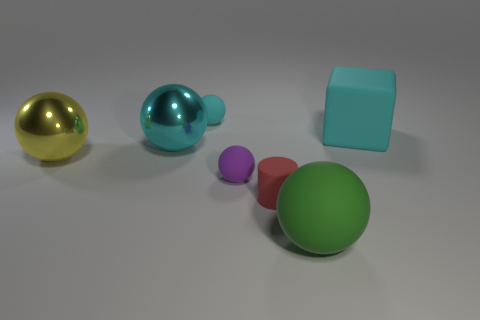Add 1 big yellow matte spheres. How many objects exist? 8 Subtract all small cyan balls. How many balls are left? 4 Subtract all blocks. How many objects are left? 6 Subtract all yellow spheres. How many spheres are left? 4 Subtract all cyan blocks. How many green balls are left? 1 Subtract all matte spheres. Subtract all large matte objects. How many objects are left? 2 Add 3 tiny cyan balls. How many tiny cyan balls are left? 4 Add 7 cyan things. How many cyan things exist? 10 Subtract 0 red balls. How many objects are left? 7 Subtract 1 blocks. How many blocks are left? 0 